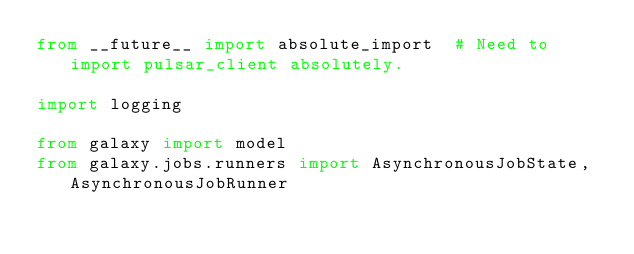<code> <loc_0><loc_0><loc_500><loc_500><_Python_>from __future__ import absolute_import  # Need to import pulsar_client absolutely.

import logging

from galaxy import model
from galaxy.jobs.runners import AsynchronousJobState, AsynchronousJobRunner</code> 